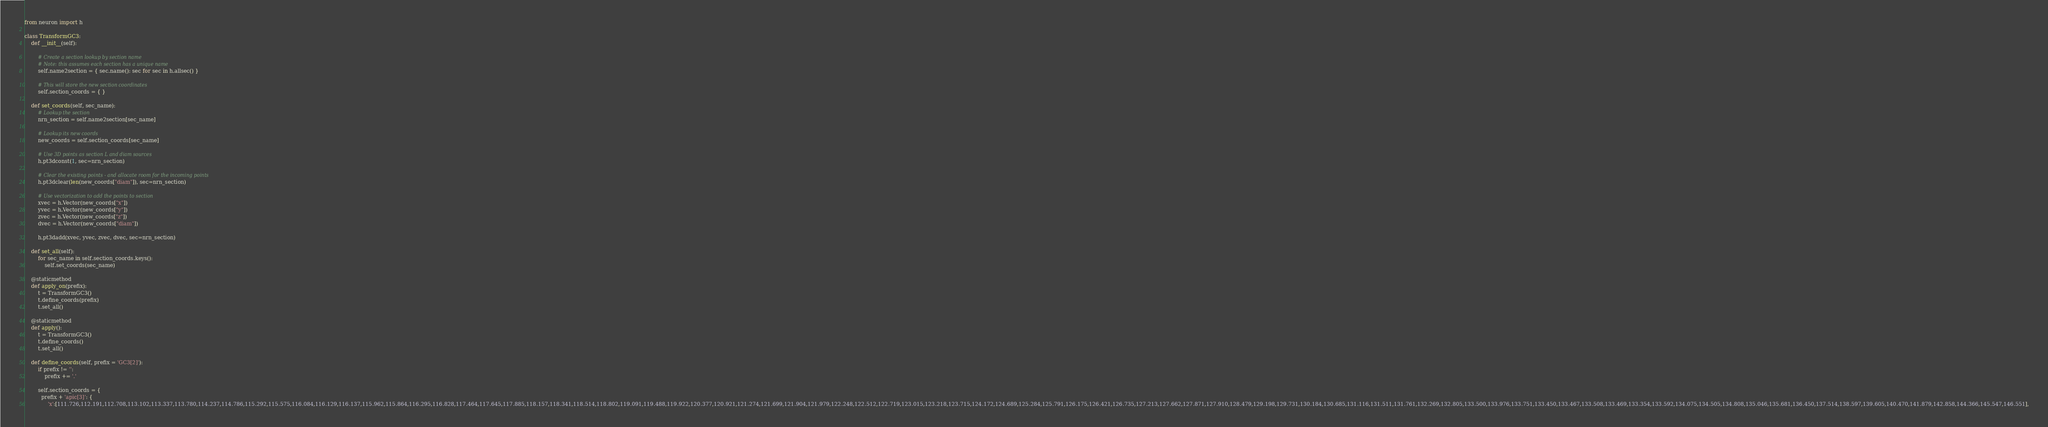<code> <loc_0><loc_0><loc_500><loc_500><_Python_>
from neuron import h

class TransformGC3:
    def __init__(self):

        # Create a section lookup by section name
        # Note: this assumes each section has a unique name
        self.name2section = { sec.name(): sec for sec in h.allsec() }

        # This will store the new section coordinates
        self.section_coords = { }

    def set_coords(self, sec_name):
        # Lookup the section
        nrn_section = self.name2section[sec_name]

        # Lookup its new coords
        new_coords = self.section_coords[sec_name]

        # Use 3D points as section L and diam sources
        h.pt3dconst(1, sec=nrn_section)

        # Clear the existing points - and allocate room for the incoming points
        h.pt3dclear(len(new_coords["diam"]), sec=nrn_section)

        # Use vectorization to add the points to section
        xvec = h.Vector(new_coords["x"])
        yvec = h.Vector(new_coords["y"])
        zvec = h.Vector(new_coords["z"])
        dvec = h.Vector(new_coords["diam"])

        h.pt3dadd(xvec, yvec, zvec, dvec, sec=nrn_section)

    def set_all(self):
        for sec_name in self.section_coords.keys():
            self.set_coords(sec_name)

    @staticmethod
    def apply_on(prefix):
        t = TransformGC3()
        t.define_coords(prefix)
        t.set_all()

    @staticmethod
    def apply():
        t = TransformGC3()
        t.define_coords()
        t.set_all()

    def define_coords(self, prefix = 'GC3[2]'):
        if prefix != '':
            prefix += '.'

        self.section_coords = {
          prefix + 'apic[3]': {
              'x':[111.726,112.191,112.708,113.102,113.337,113.780,114.237,114.786,115.292,115.575,116.084,116.129,116.137,115.962,115.864,116.295,116.828,117.464,117.645,117.885,118.157,118.341,118.514,118.802,119.091,119.488,119.922,120.377,120.921,121.274,121.699,121.904,121.979,122.248,122.512,122.719,123.015,123.218,123.715,124.172,124.689,125.284,125.791,126.175,126.421,126.735,127.213,127.662,127.871,127.910,128.479,129.198,129.731,130.184,130.685,131.116,131.511,131.761,132.269,132.805,133.500,133.976,133.751,133.450,133.467,133.508,133.469,133.354,133.592,134.075,134.505,134.808,135.046,135.681,136.450,137.514,138.597,139.605,140.470,141.879,142.858,144.366,145.547,146.551],</code> 